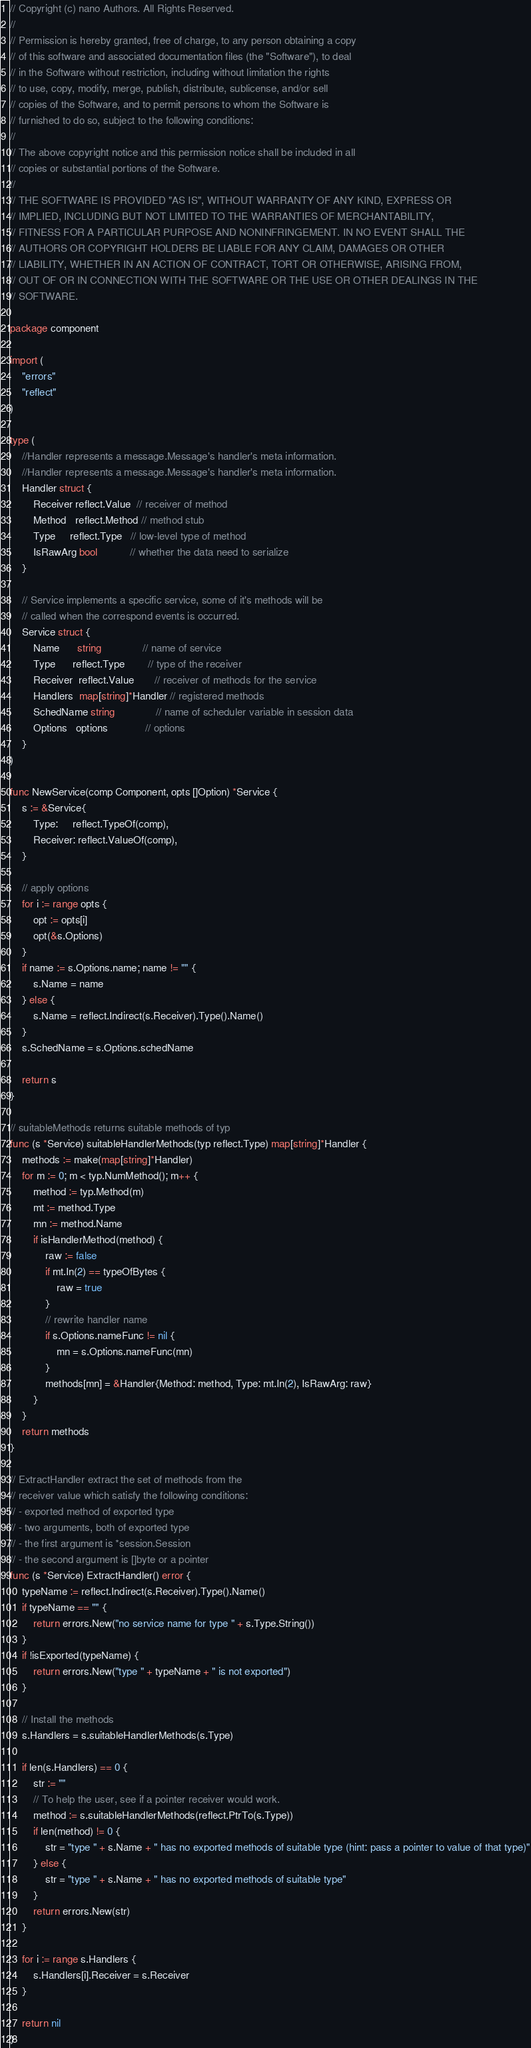Convert code to text. <code><loc_0><loc_0><loc_500><loc_500><_Go_>// Copyright (c) nano Authors. All Rights Reserved.
//
// Permission is hereby granted, free of charge, to any person obtaining a copy
// of this software and associated documentation files (the "Software"), to deal
// in the Software without restriction, including without limitation the rights
// to use, copy, modify, merge, publish, distribute, sublicense, and/or sell
// copies of the Software, and to permit persons to whom the Software is
// furnished to do so, subject to the following conditions:
//
// The above copyright notice and this permission notice shall be included in all
// copies or substantial portions of the Software.
//
// THE SOFTWARE IS PROVIDED "AS IS", WITHOUT WARRANTY OF ANY KIND, EXPRESS OR
// IMPLIED, INCLUDING BUT NOT LIMITED TO THE WARRANTIES OF MERCHANTABILITY,
// FITNESS FOR A PARTICULAR PURPOSE AND NONINFRINGEMENT. IN NO EVENT SHALL THE
// AUTHORS OR COPYRIGHT HOLDERS BE LIABLE FOR ANY CLAIM, DAMAGES OR OTHER
// LIABILITY, WHETHER IN AN ACTION OF CONTRACT, TORT OR OTHERWISE, ARISING FROM,
// OUT OF OR IN CONNECTION WITH THE SOFTWARE OR THE USE OR OTHER DEALINGS IN THE
// SOFTWARE.

package component

import (
	"errors"
	"reflect"
)

type (
	//Handler represents a message.Message's handler's meta information.
	//Handler represents a message.Message's handler's meta information.
	Handler struct {
		Receiver reflect.Value  // receiver of method
		Method   reflect.Method // method stub
		Type     reflect.Type   // low-level type of method
		IsRawArg bool           // whether the data need to serialize
	}

	// Service implements a specific service, some of it's methods will be
	// called when the correspond events is occurred.
	Service struct {
		Name      string              // name of service
		Type      reflect.Type        // type of the receiver
		Receiver  reflect.Value       // receiver of methods for the service
		Handlers  map[string]*Handler // registered methods
		SchedName string              // name of scheduler variable in session data
		Options   options             // options
	}
)

func NewService(comp Component, opts []Option) *Service {
	s := &Service{
		Type:     reflect.TypeOf(comp),
		Receiver: reflect.ValueOf(comp),
	}

	// apply options
	for i := range opts {
		opt := opts[i]
		opt(&s.Options)
	}
	if name := s.Options.name; name != "" {
		s.Name = name
	} else {
		s.Name = reflect.Indirect(s.Receiver).Type().Name()
	}
	s.SchedName = s.Options.schedName

	return s
}

// suitableMethods returns suitable methods of typ
func (s *Service) suitableHandlerMethods(typ reflect.Type) map[string]*Handler {
	methods := make(map[string]*Handler)
	for m := 0; m < typ.NumMethod(); m++ {
		method := typ.Method(m)
		mt := method.Type
		mn := method.Name
		if isHandlerMethod(method) {
			raw := false
			if mt.In(2) == typeOfBytes {
				raw = true
			}
			// rewrite handler name
			if s.Options.nameFunc != nil {
				mn = s.Options.nameFunc(mn)
			}
			methods[mn] = &Handler{Method: method, Type: mt.In(2), IsRawArg: raw}
		}
	}
	return methods
}

// ExtractHandler extract the set of methods from the
// receiver value which satisfy the following conditions:
// - exported method of exported type
// - two arguments, both of exported type
// - the first argument is *session.Session
// - the second argument is []byte or a pointer
func (s *Service) ExtractHandler() error {
	typeName := reflect.Indirect(s.Receiver).Type().Name()
	if typeName == "" {
		return errors.New("no service name for type " + s.Type.String())
	}
	if !isExported(typeName) {
		return errors.New("type " + typeName + " is not exported")
	}

	// Install the methods
	s.Handlers = s.suitableHandlerMethods(s.Type)

	if len(s.Handlers) == 0 {
		str := ""
		// To help the user, see if a pointer receiver would work.
		method := s.suitableHandlerMethods(reflect.PtrTo(s.Type))
		if len(method) != 0 {
			str = "type " + s.Name + " has no exported methods of suitable type (hint: pass a pointer to value of that type)"
		} else {
			str = "type " + s.Name + " has no exported methods of suitable type"
		}
		return errors.New(str)
	}

	for i := range s.Handlers {
		s.Handlers[i].Receiver = s.Receiver
	}

	return nil
}
</code> 